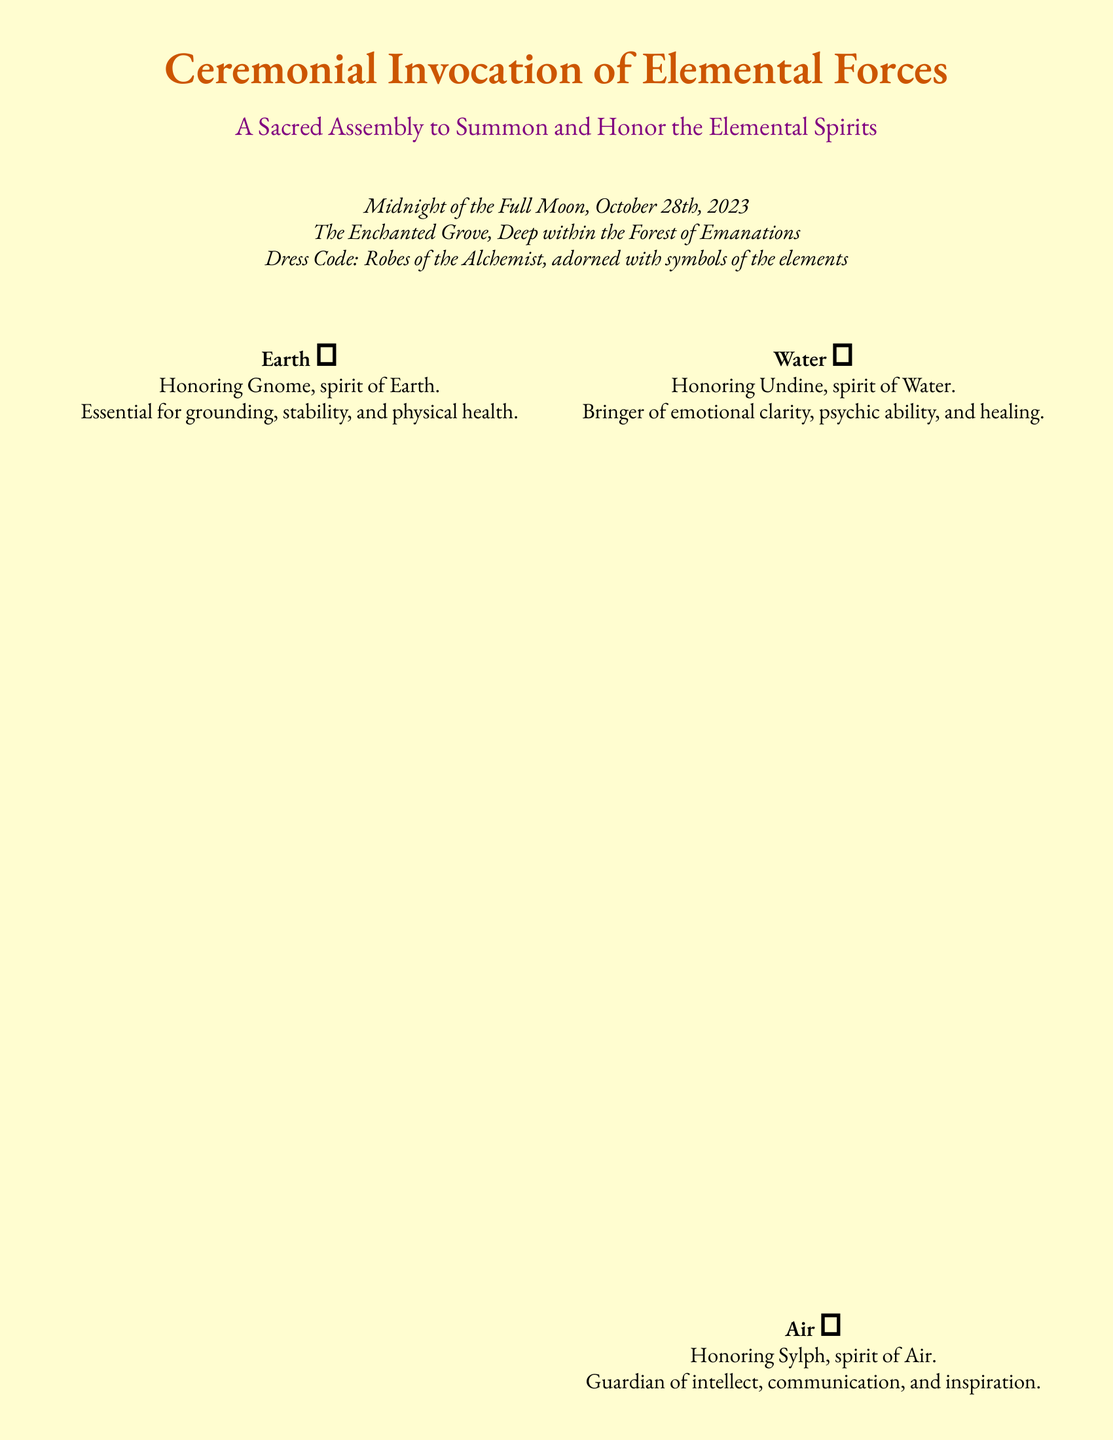What is the date of the ceremony? The date of the ceremony is specified in the document, which is midnight of the Full Moon on October 28th, 2023.
Answer: October 28th, 2023 Where is the ceremony taking place? The document indicates that the ceremony is held in The Enchanted Grove, Deep within the Forest of Emanations.
Answer: The Enchanted Grove What attire is required for the attendees? The document mentions a dress code for the assembly, specifying that attendees should wear Robes of the Alchemist adorned with symbols of the elements.
Answer: Robes of the Alchemist Who is the spirit of Earth? The document states that the spirit of Earth is Gnome, which is to be honored during the ceremony.
Answer: Gnome What elements can participants choose from for their protective talisman? The document lists four elements that participants can choose, which are Earth, Water, Air, and Fire as protective talismans.
Answer: Earth, Water, Air, Fire What is the RSVP deadline? The document provides a specific date by which attendees must RSVP, which is stated as October 14th, 2023.
Answer: October 14th, 2023 What type of card is this document? The document is structured as an RSVP card specifically for a ceremonial event related to elemental forces.
Answer: RSVP card What is the purpose of the assembly? The document states that the purpose of the assembly is to summon and honor the elemental spirits.
Answer: Summon and honor the elemental spirits 